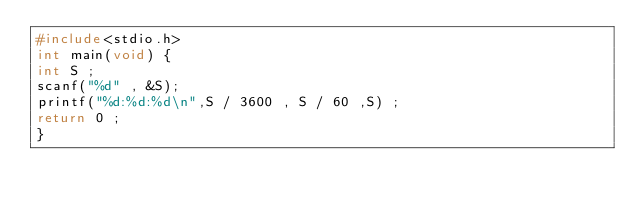<code> <loc_0><loc_0><loc_500><loc_500><_C_>#include<stdio.h>
int main(void) {
int S ;
scanf("%d" , &S);
printf("%d:%d:%d\n",S / 3600 , S / 60 ,S) ;
return 0 ;
}</code> 